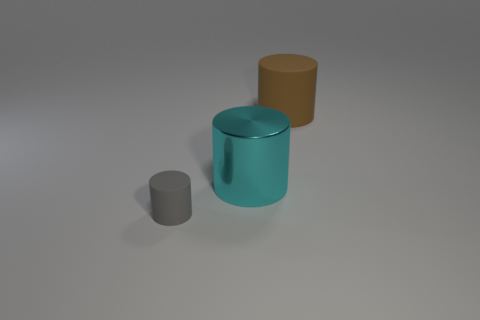Add 3 large gray matte balls. How many objects exist? 6 Add 1 large blue cubes. How many large blue cubes exist? 1 Subtract 0 green cylinders. How many objects are left? 3 Subtract all big cyan shiny things. Subtract all tiny gray matte objects. How many objects are left? 1 Add 3 big brown rubber cylinders. How many big brown rubber cylinders are left? 4 